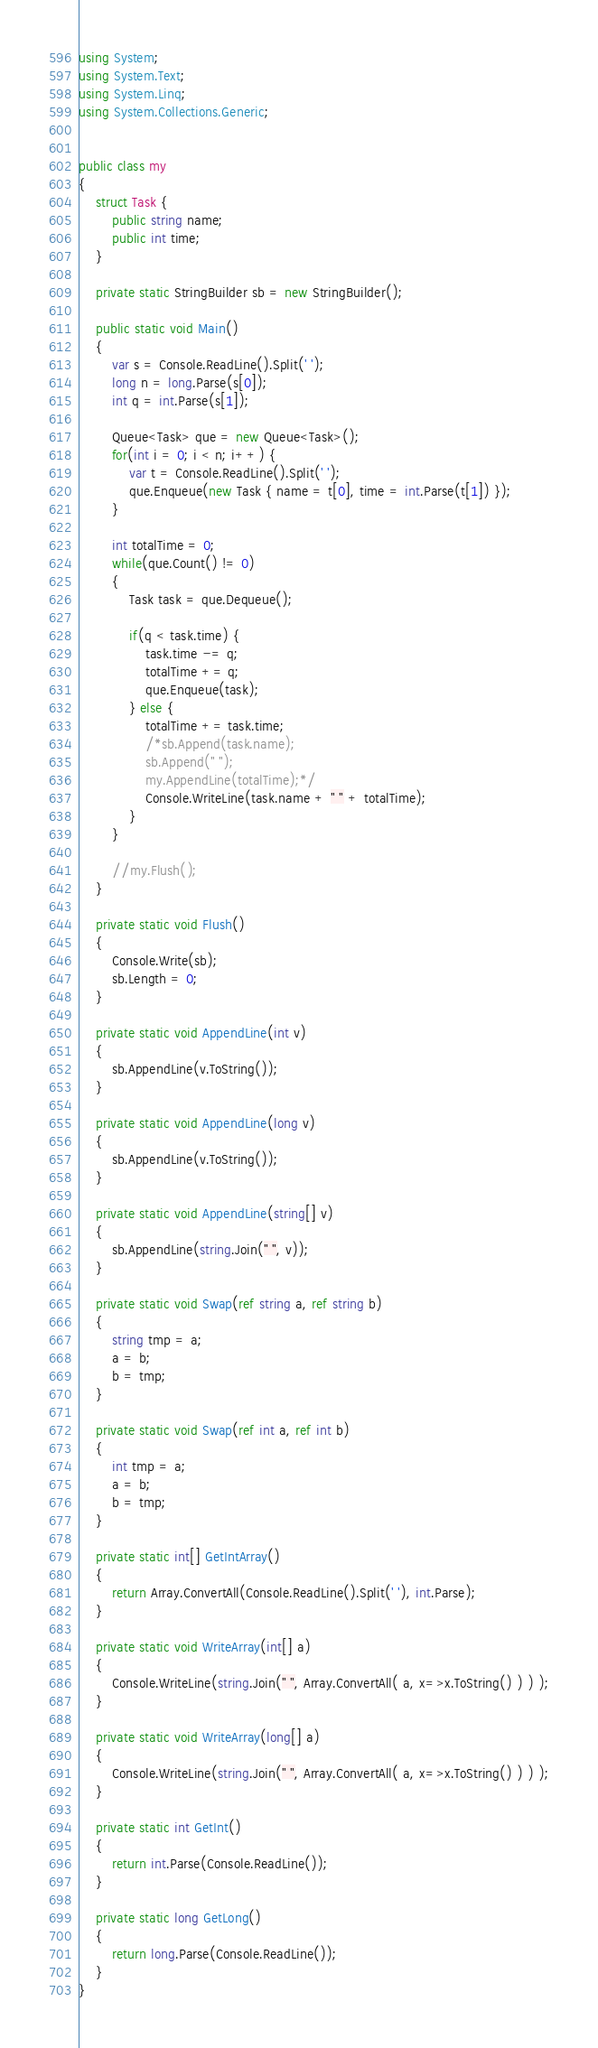Convert code to text. <code><loc_0><loc_0><loc_500><loc_500><_C#_>using System;
using System.Text;
using System.Linq;
using System.Collections.Generic;


public class my
{
	struct Task {
		public string name;
		public int time;
	}
	
	private static StringBuilder sb = new StringBuilder();
	
	public static void Main()
	{
		var s = Console.ReadLine().Split(' ');
		long n = long.Parse(s[0]);
		int q = int.Parse(s[1]);
		
		Queue<Task> que = new Queue<Task>();
		for(int i = 0; i < n; i++) {
			var t = Console.ReadLine().Split(' ');
			que.Enqueue(new Task { name = t[0], time = int.Parse(t[1]) });
		}
		
		int totalTime = 0;
		while(que.Count() != 0)
		{
			Task task = que.Dequeue();
			
			if(q < task.time) {
				task.time -= q;
				totalTime += q;
				que.Enqueue(task);
			} else {
				totalTime += task.time;
				/*sb.Append(task.name);
				sb.Append(" ");
				my.AppendLine(totalTime);*/
				Console.WriteLine(task.name + " " + totalTime);
			}
		}
		
		//my.Flush();
	}
	
	private static void Flush()
	{
		Console.Write(sb);
		sb.Length = 0;
	}
	
	private static void AppendLine(int v)
	{
		sb.AppendLine(v.ToString());
	}
	
	private static void AppendLine(long v)
	{
		sb.AppendLine(v.ToString());
	}
	
	private static void AppendLine(string[] v)
	{
		sb.AppendLine(string.Join(" ", v));
	}
	
	private static void Swap(ref string a, ref string b) 
	{
		string tmp = a;
		a = b;
		b = tmp;
	}
	
	private static void Swap(ref int a, ref int b) 
	{
		int tmp = a;
		a = b;
		b = tmp;
	}
	
	private static int[] GetIntArray()
	{
		return Array.ConvertAll(Console.ReadLine().Split(' '), int.Parse);
	}
	
	private static void WriteArray(int[] a)
	{
		Console.WriteLine(string.Join(" ", Array.ConvertAll( a, x=>x.ToString() ) ) );
	}
	
	private static void WriteArray(long[] a)
	{
		Console.WriteLine(string.Join(" ", Array.ConvertAll( a, x=>x.ToString() ) ) );
	}
	
	private static int GetInt()
	{
		return int.Parse(Console.ReadLine());
	}
	
	private static long GetLong()
	{
		return long.Parse(Console.ReadLine());
	}
}</code> 